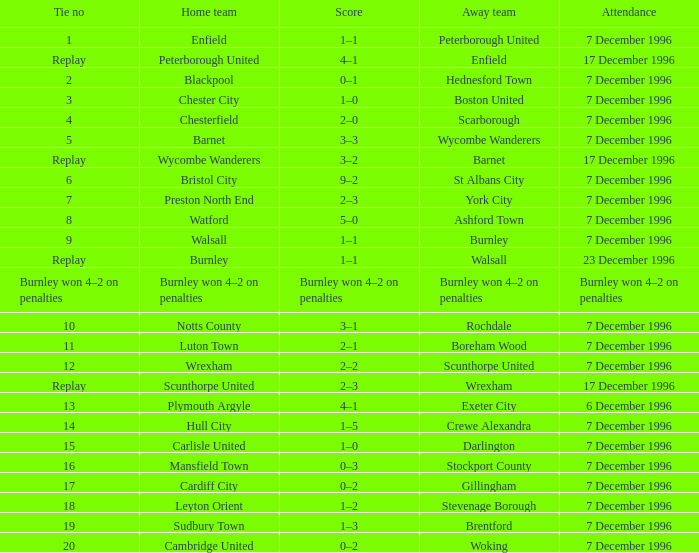I'm looking to parse the entire table for insights. Could you assist me with that? {'header': ['Tie no', 'Home team', 'Score', 'Away team', 'Attendance'], 'rows': [['1', 'Enfield', '1–1', 'Peterborough United', '7 December 1996'], ['Replay', 'Peterborough United', '4–1', 'Enfield', '17 December 1996'], ['2', 'Blackpool', '0–1', 'Hednesford Town', '7 December 1996'], ['3', 'Chester City', '1–0', 'Boston United', '7 December 1996'], ['4', 'Chesterfield', '2–0', 'Scarborough', '7 December 1996'], ['5', 'Barnet', '3–3', 'Wycombe Wanderers', '7 December 1996'], ['Replay', 'Wycombe Wanderers', '3–2', 'Barnet', '17 December 1996'], ['6', 'Bristol City', '9–2', 'St Albans City', '7 December 1996'], ['7', 'Preston North End', '2–3', 'York City', '7 December 1996'], ['8', 'Watford', '5–0', 'Ashford Town', '7 December 1996'], ['9', 'Walsall', '1–1', 'Burnley', '7 December 1996'], ['Replay', 'Burnley', '1–1', 'Walsall', '23 December 1996'], ['Burnley won 4–2 on penalties', 'Burnley won 4–2 on penalties', 'Burnley won 4–2 on penalties', 'Burnley won 4–2 on penalties', 'Burnley won 4–2 on penalties'], ['10', 'Notts County', '3–1', 'Rochdale', '7 December 1996'], ['11', 'Luton Town', '2–1', 'Boreham Wood', '7 December 1996'], ['12', 'Wrexham', '2–2', 'Scunthorpe United', '7 December 1996'], ['Replay', 'Scunthorpe United', '2–3', 'Wrexham', '17 December 1996'], ['13', 'Plymouth Argyle', '4–1', 'Exeter City', '6 December 1996'], ['14', 'Hull City', '1–5', 'Crewe Alexandra', '7 December 1996'], ['15', 'Carlisle United', '1–0', 'Darlington', '7 December 1996'], ['16', 'Mansfield Town', '0–3', 'Stockport County', '7 December 1996'], ['17', 'Cardiff City', '0–2', 'Gillingham', '7 December 1996'], ['18', 'Leyton Orient', '1–2', 'Stevenage Borough', '7 December 1996'], ['19', 'Sudbury Town', '1–3', 'Brentford', '7 December 1996'], ['20', 'Cambridge United', '0–2', 'Woking', '7 December 1996']]} What was the point tally for tie number 15? 1–0. 